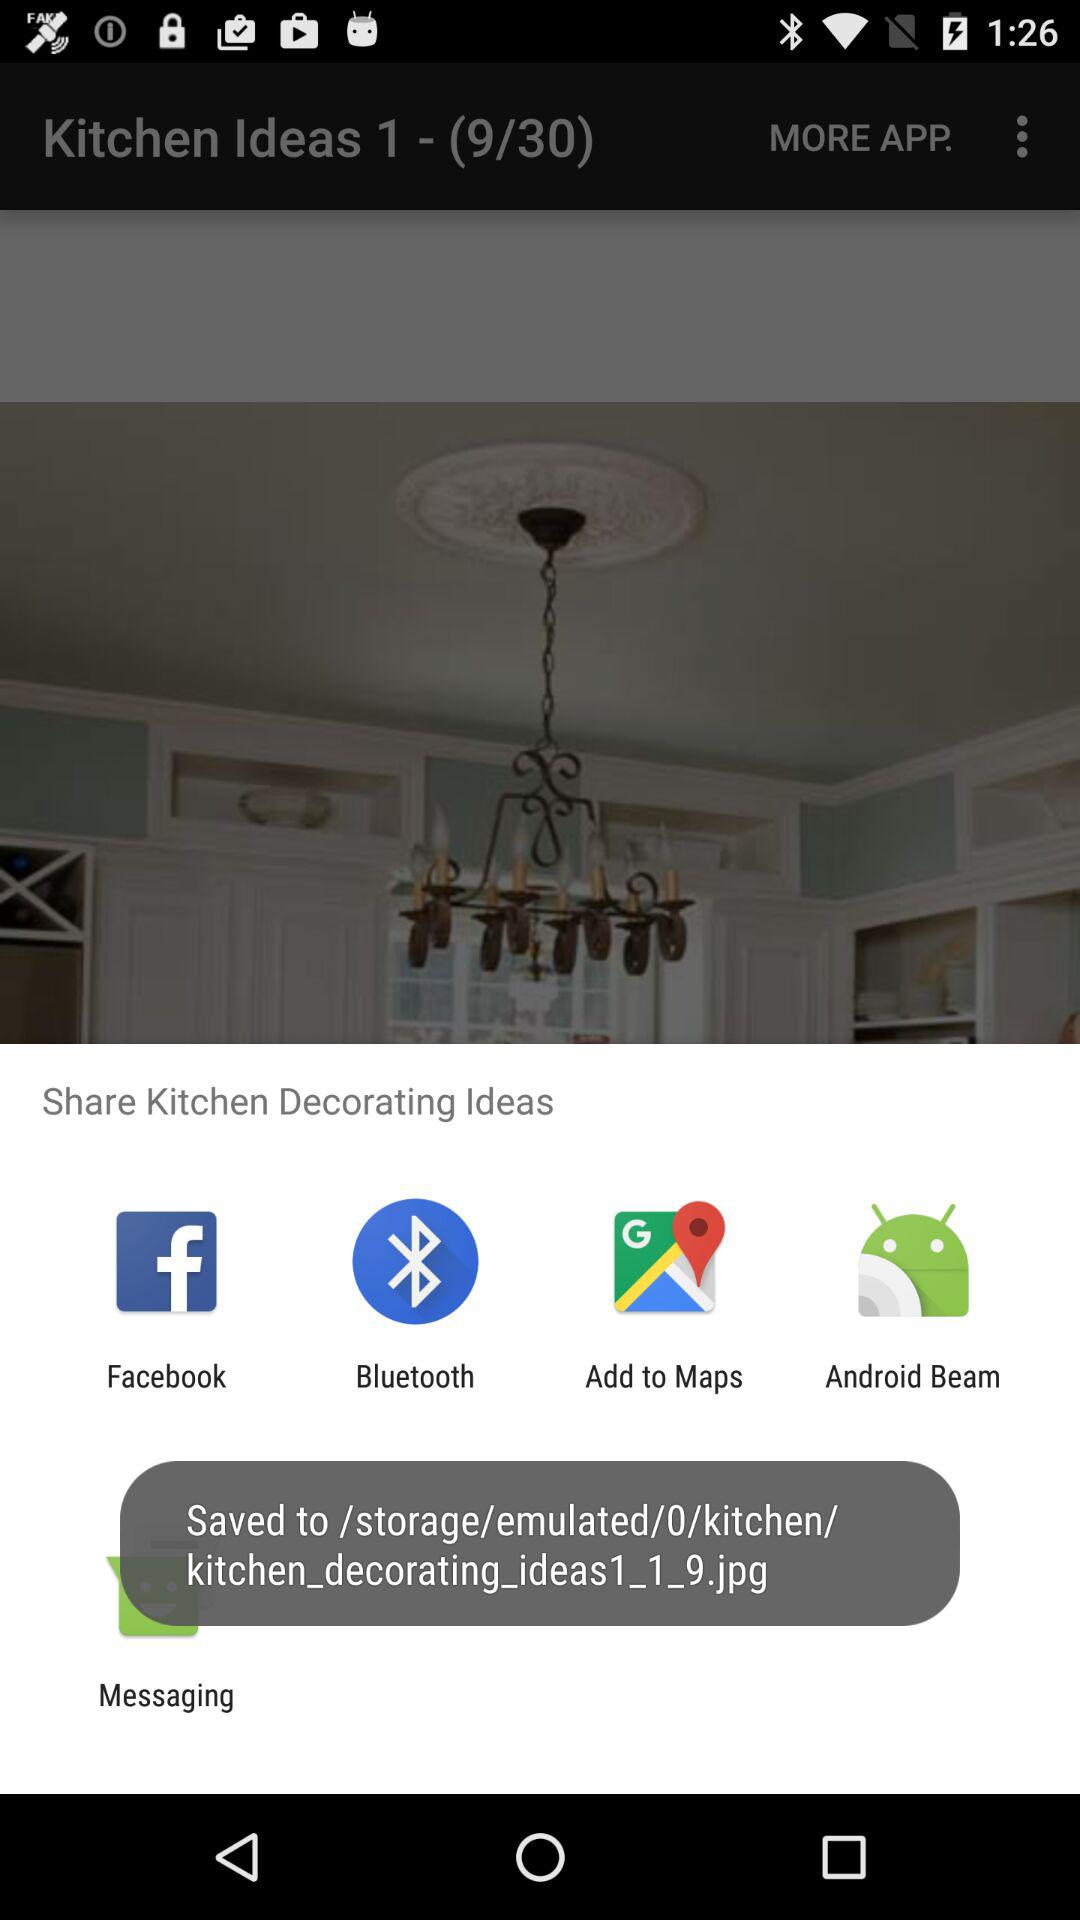On which image number are we right now? You are on image number 9 right now. 